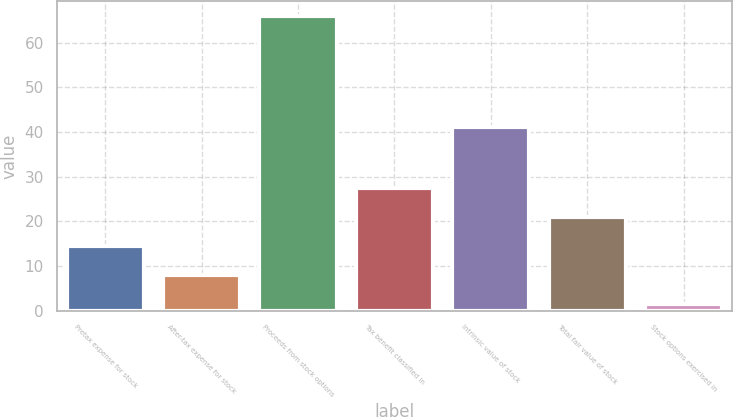<chart> <loc_0><loc_0><loc_500><loc_500><bar_chart><fcel>Pretax expense for stock<fcel>After-tax expense for stock<fcel>Proceeds from stock options<fcel>Tax benefit classified in<fcel>Intrinsic value of stock<fcel>Total fair value of stock<fcel>Stock options exercised in<nl><fcel>14.45<fcel>8<fcel>66<fcel>27.35<fcel>41<fcel>20.9<fcel>1.5<nl></chart> 